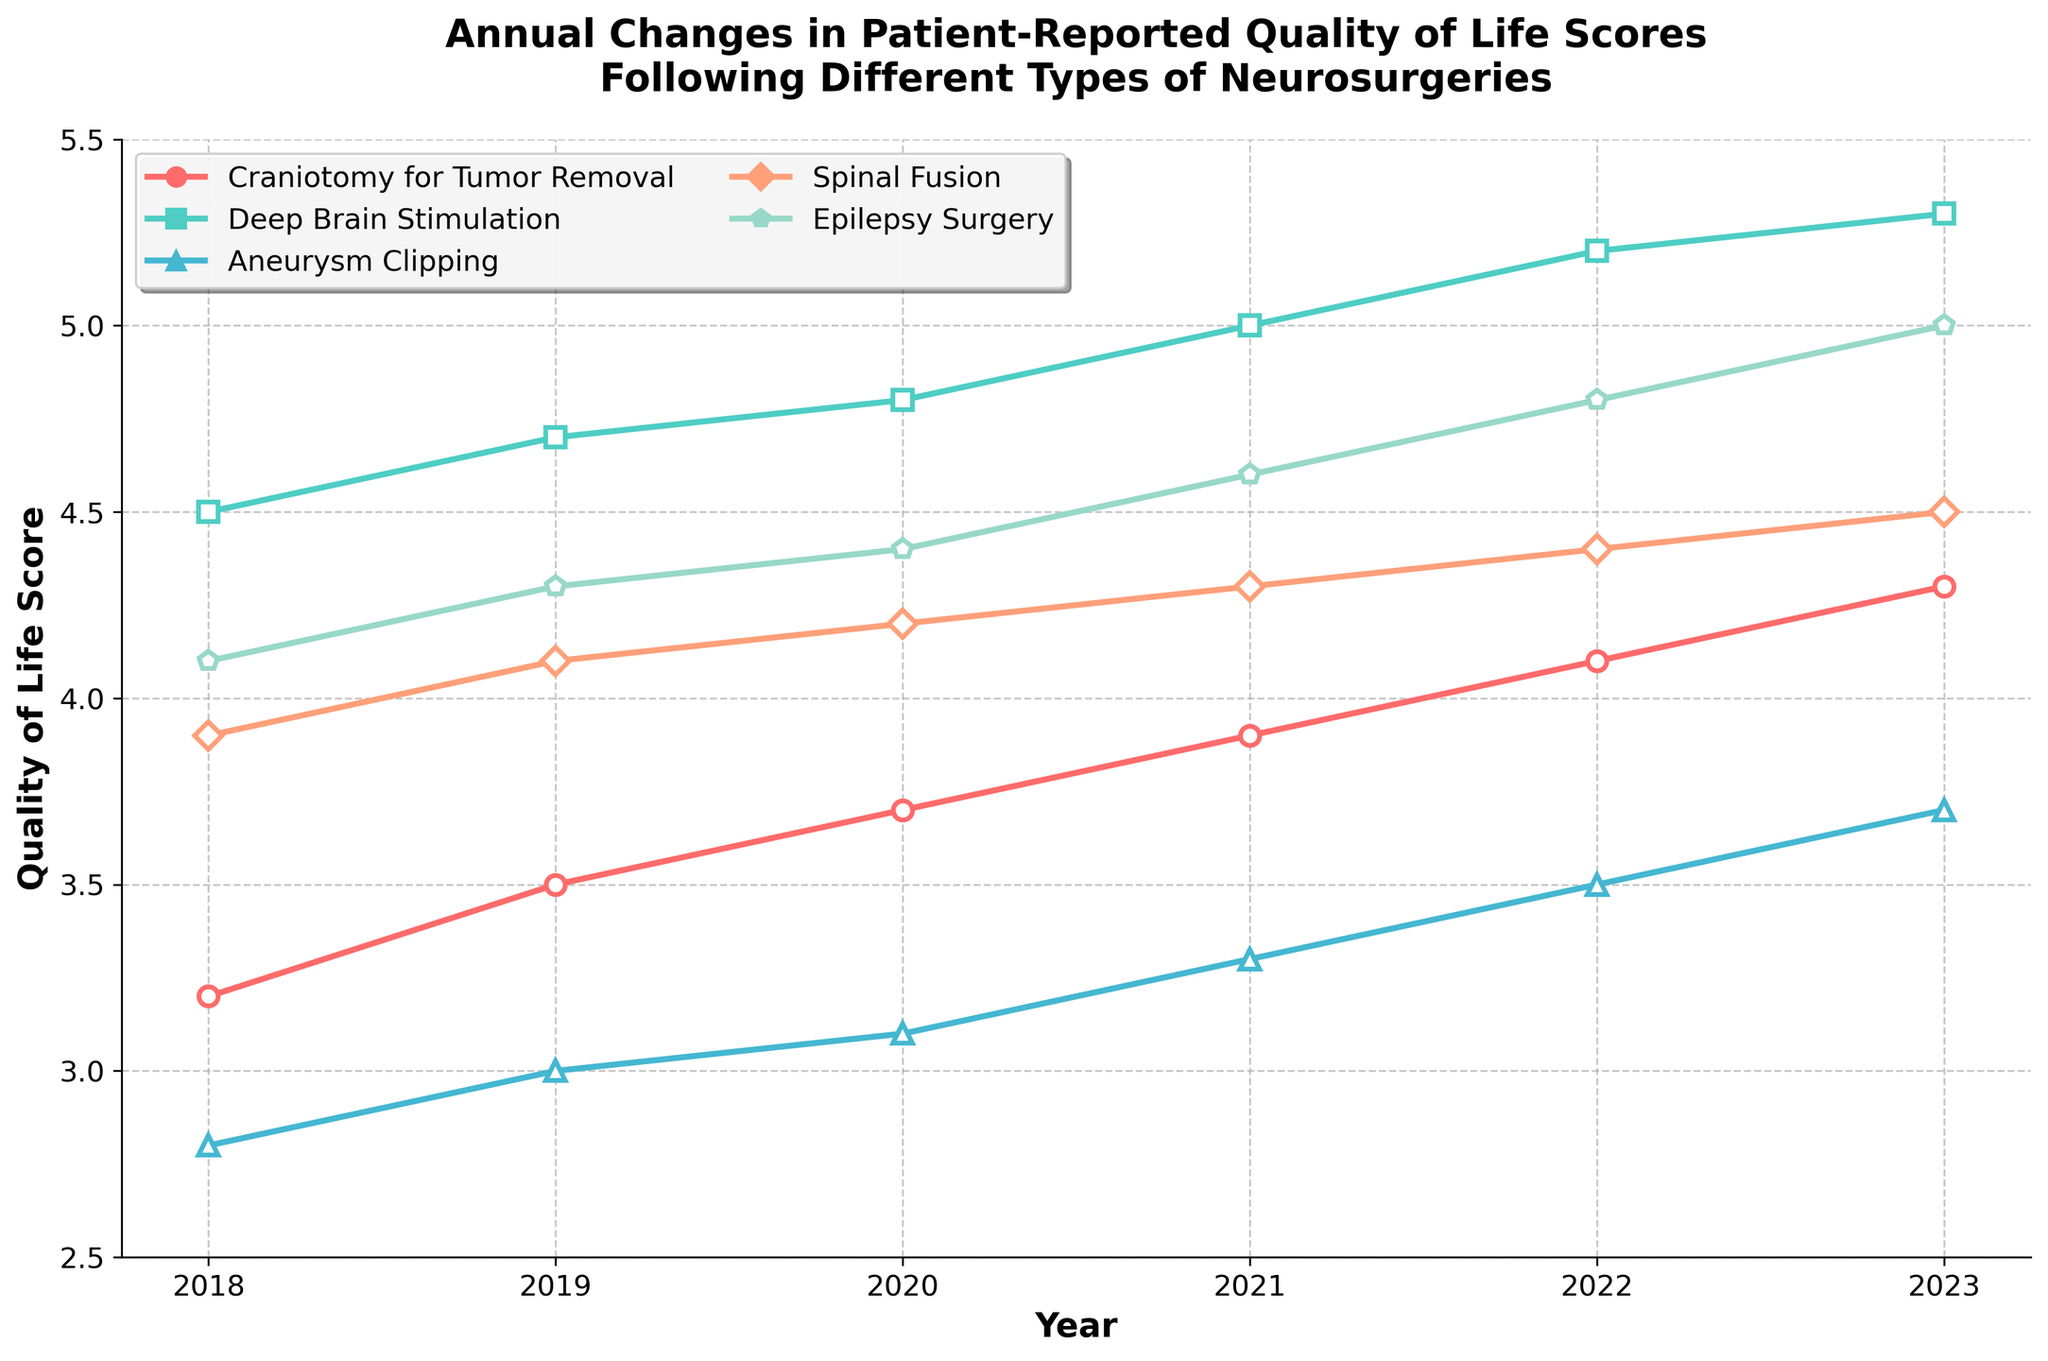What is the quality of life score for Deep Brain Stimulation in 2021? From the line chart, locate the point corresponding to the year 2021 for the Deep Brain Stimulation line, which is represented by its specific color and marker. The y-axis value of this point represents the quality of life score.
Answer: 5.0 Which neurosurgery type shows the highest increase in quality of life score from 2018 to 2023? To determine this, calculate the increase for each surgery type by subtracting the 2018 score from the 2023 score. Then, compare these increases to find the highest one. The increases are: Craniotomy for Tumor Removal (4.3 - 3.2 = 1.1), Deep Brain Stimulation (5.3 - 4.5 = 0.8), Aneurysm Clipping (3.7 - 2.8 = 0.9), Spinal Fusion (4.5 - 3.9 = 0.6), and Epilepsy Surgery (5.0 - 4.1 = 0.9). Thus, Craniotomy for Tumor Removal shows the highest increase.
Answer: Craniotomy for Tumor Removal What is the average quality of life score for Epilepsy Surgery from 2018 to 2023? Sum up the yearly scores for Epilepsy Surgery from 2018 to 2023 and then divide by the number of years (6). (4.1 + 4.3 + 4.4 + 4.6 + 4.8 + 5.0) / 6 = 27.2 / 6
Answer: 4.53 How does the quality of life score for Spinal Fusion in 2020 compare to that in 2023? Look at the scores for Spinal Fusion in 2020 and 2023 from the chart and compare them. The score in 2020 is 4.2 and in 2023 is 4.5. Therefore, the score has increased by 0.3.
Answer: Increased by 0.3 Which year saw the largest increase in quality of life score for Craniotomy for Tumor Removal? Calculate the yearly change for Craniotomy for Tumor Removal and identify the year with the largest increase. The increases are: 2018-2019 (3.5 - 3.2 = 0.3), 2019-2020 (3.7 - 3.5 = 0.2), 2020-2021 (3.9 - 3.7 = 0.2), 2021-2022 (4.1 - 3.9 = 0.2), 2022-2023 (4.3 - 4.1 = 0.2). Thus, the largest increase is from 2018 to 2019.
Answer: 2018 to 2019 Compare the pattern of annual changes in quality of life scores between Aneurysm Clipping and Spinal Fusion. Observe the trends in quality of life scores for both Aneurysm Clipping and Spinal Fusion. Each year, Aneurysm Clipping shows a consistent increase from 2.8 to 3.7 (an overall increase of 0.9), while Spinal Fusion also shows consistent increases from 3.9 to 4.5 (an overall increase of 0.6). Aneurysm Clipping tends to have a slightly smaller annual increase compared to Spinal Fusion.
Answer: Aneurysm Clipping increases more but by smaller annual increments 